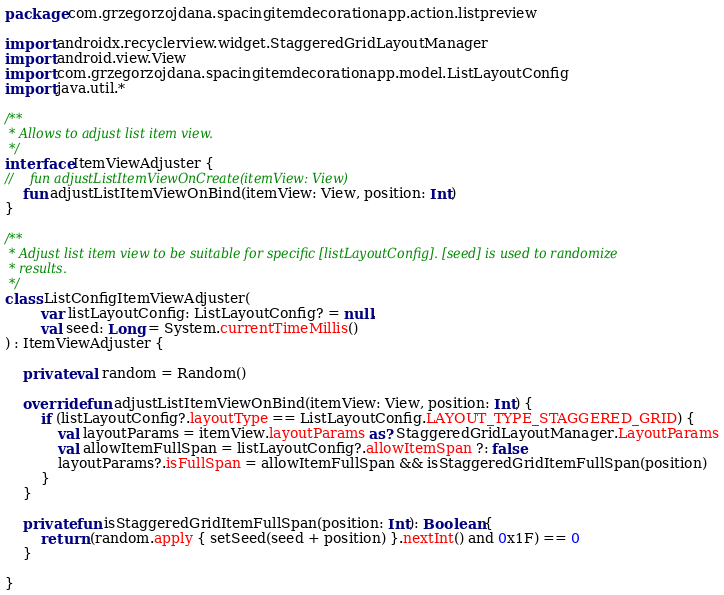<code> <loc_0><loc_0><loc_500><loc_500><_Kotlin_>package com.grzegorzojdana.spacingitemdecorationapp.action.listpreview

import androidx.recyclerview.widget.StaggeredGridLayoutManager
import android.view.View
import com.grzegorzojdana.spacingitemdecorationapp.model.ListLayoutConfig
import java.util.*

/**
 * Allows to adjust list item view.
 */
interface ItemViewAdjuster {
//    fun adjustListItemViewOnCreate(itemView: View)
    fun adjustListItemViewOnBind(itemView: View, position: Int)
}

/**
 * Adjust list item view to be suitable for specific [listLayoutConfig]. [seed] is used to randomize
 * results.
 */
class ListConfigItemViewAdjuster(
        var listLayoutConfig: ListLayoutConfig? = null,
        val seed: Long = System.currentTimeMillis()
) : ItemViewAdjuster {

    private val random = Random()

    override fun adjustListItemViewOnBind(itemView: View, position: Int) {
        if (listLayoutConfig?.layoutType == ListLayoutConfig.LAYOUT_TYPE_STAGGERED_GRID) {
            val layoutParams = itemView.layoutParams as? StaggeredGridLayoutManager.LayoutParams
            val allowItemFullSpan = listLayoutConfig?.allowItemSpan ?: false
            layoutParams?.isFullSpan = allowItemFullSpan && isStaggeredGridItemFullSpan(position)
        }
    }

    private fun isStaggeredGridItemFullSpan(position: Int): Boolean {
        return (random.apply { setSeed(seed + position) }.nextInt() and 0x1F) == 0
    }

}</code> 